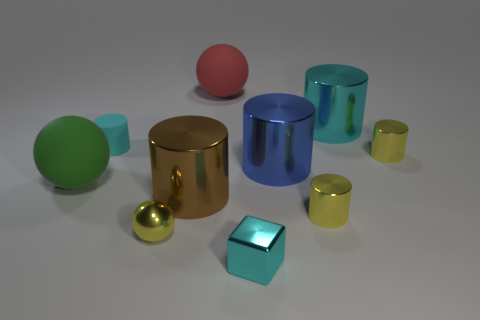Subtract all cyan cylinders. How many cylinders are left? 4 Subtract all yellow metal cylinders. How many cylinders are left? 4 Subtract all green cylinders. Subtract all blue cubes. How many cylinders are left? 6 Subtract all cubes. How many objects are left? 9 Add 9 large red metallic objects. How many large red metallic objects exist? 9 Subtract 0 cyan spheres. How many objects are left? 10 Subtract all brown cylinders. Subtract all tiny shiny spheres. How many objects are left? 8 Add 5 cyan matte cylinders. How many cyan matte cylinders are left? 6 